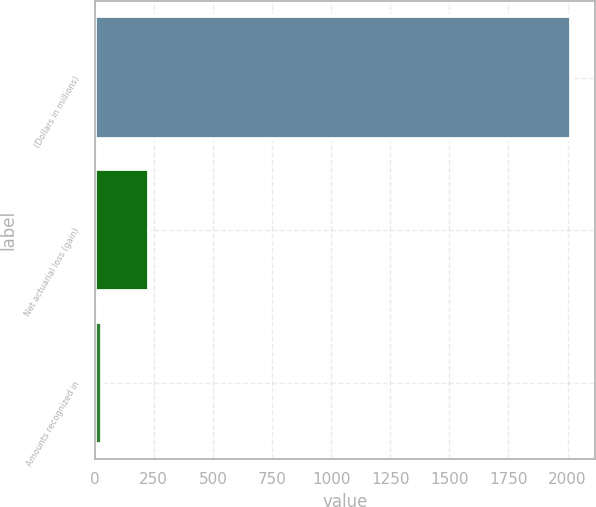Convert chart to OTSL. <chart><loc_0><loc_0><loc_500><loc_500><bar_chart><fcel>(Dollars in millions)<fcel>Net actuarial loss (gain)<fcel>Amounts recognized in<nl><fcel>2016<fcel>230.4<fcel>32<nl></chart> 